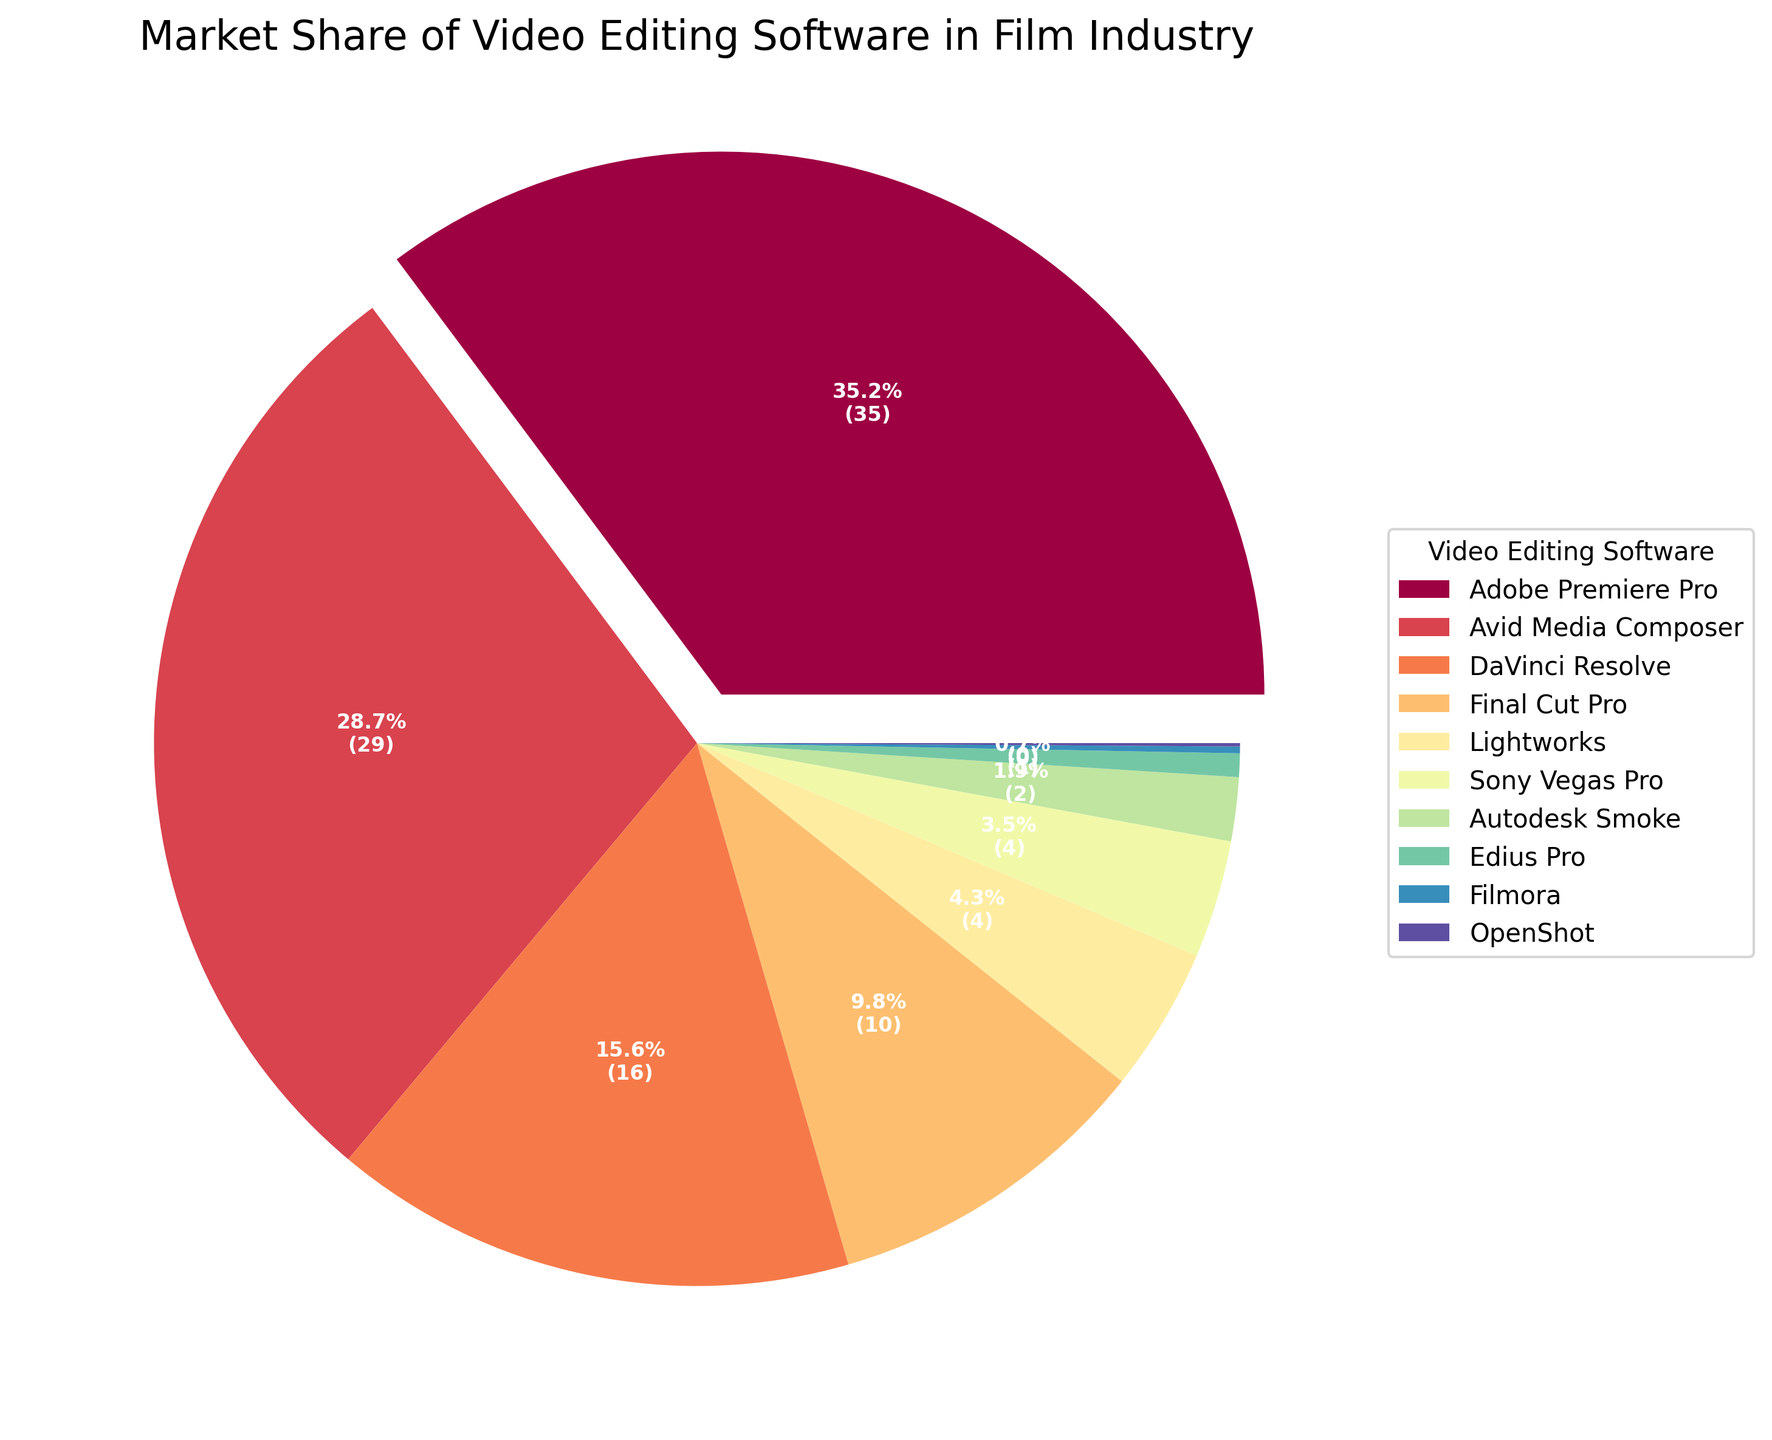What's the software with the largest market share in the film industry? The pie chart shows market shares for various video editing software. The largest segment, indicated by the exploded section, belongs to Adobe Premiere Pro.
Answer: Adobe Premiere Pro Which two software have the smallest market share combined? The two smallest segments on the chart are OpenShot and Filmora. Their market shares are 0.1% and 0.2%, respectively.
Answer: OpenShot and Filmora How much higher is Adobe Premiere Pro's market share compared to Avid Media Composer? Adobe Premiere Pro has a market share of 35.2%, while Avid Media Composer has 28.7%. Subtract 28.7 from 35.2 to find the difference.
Answer: 6.5% Which software have a market share greater than 10%? The pie chart’s larger segments indicate that only Adobe Premiere Pro, Avid Media Composer, and DaVinci Resolve have shares above 10%.
Answer: Adobe Premiere Pro, Avid Media Composer, and DaVinci Resolve What is the combined market share of Final Cut Pro and Lightworks? Final Cut Pro has a market share of 9.8%, and Lightworks has 4.3%. Add these values together.
Answer: 14.1% What colors are used to represent Adobe Premiere Pro and Avid Media Composer? Adobe Premiere Pro, highlighted by the exploded wedge, uses the first color (light shade), while Avid Media Composer uses the second color (next in the spectrum).
Answer: Light shade for Adobe Premiere Pro and a darker adjacent shade for Avid Media Composer Which software has a slightly larger market share, DaVinci Resolve or Final Cut Pro? Compare the percentages for DaVinci Resolve (15.6%) and Final Cut Pro (9.8%). DaVinci Resolve has a larger market share.
Answer: DaVinci Resolve How many software have a market share below 5%? Identify the segments of the pie chart under 5%: Lightworks, Sony Vegas Pro, Autodesk Smoke, Edius Pro, Filmora, and OpenShot. Count these segments.
Answer: 6 What percent of the market share is held by software other than Adobe Premiere Pro, Avid Media Composer, and DaVinci Resolve? Sum the market shares of all software except Adobe Premiere Pro, Avid Media Composer, and DaVinci Resolve. Total is 100%; subtract the sum of 35.2% + 28.7% + 15.6%.
Answer: 20.5% How does the market share of Lightworks compare with Sony Vegas Pro? Check the pie chart for their market shares: Lightworks has 4.3%, while Sony Vegas Pro has 3.5%. Lightworks has a slightly larger market share than Sony Vegas Pro.
Answer: Lightworks has a larger share 